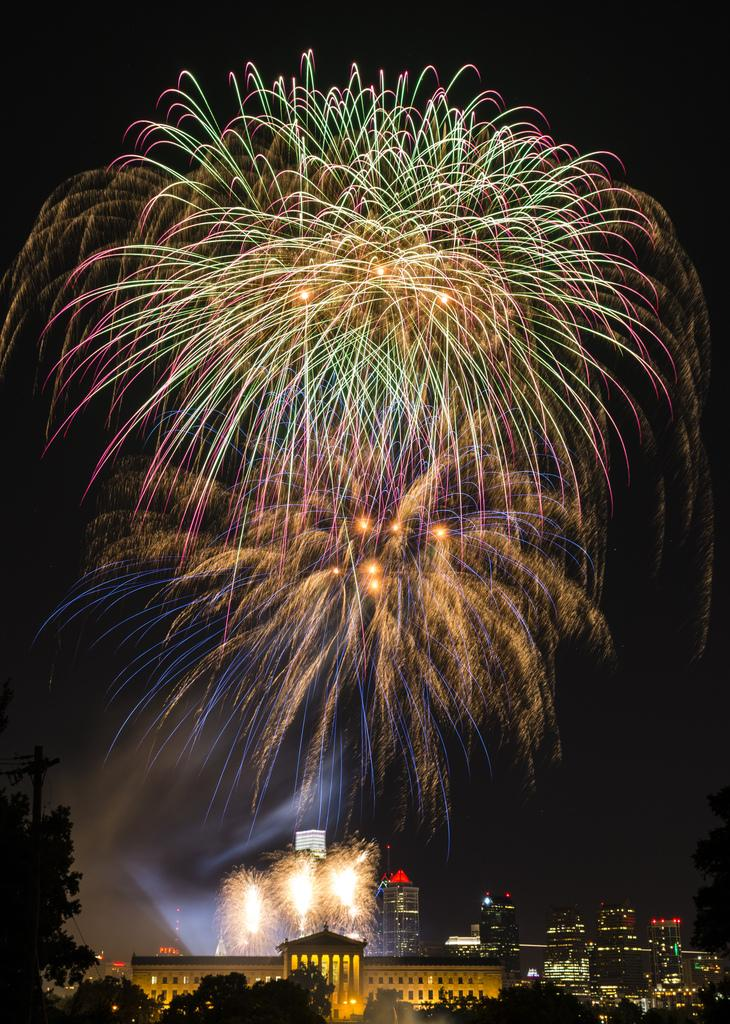What type of structures can be seen in the image? There are many houses and buildings in the image. What natural elements are present in the image? There are many trees in the image. What is visible in the background of the image? There is a sky visible in the image. What additional feature can be seen in the image? There is a firework in the image. Where is the plate with the sock placed in the image? There is no plate or sock present in the image. What type of vase can be seen holding the firework in the image? There is no vase present in the image; the firework is not held by any container. 